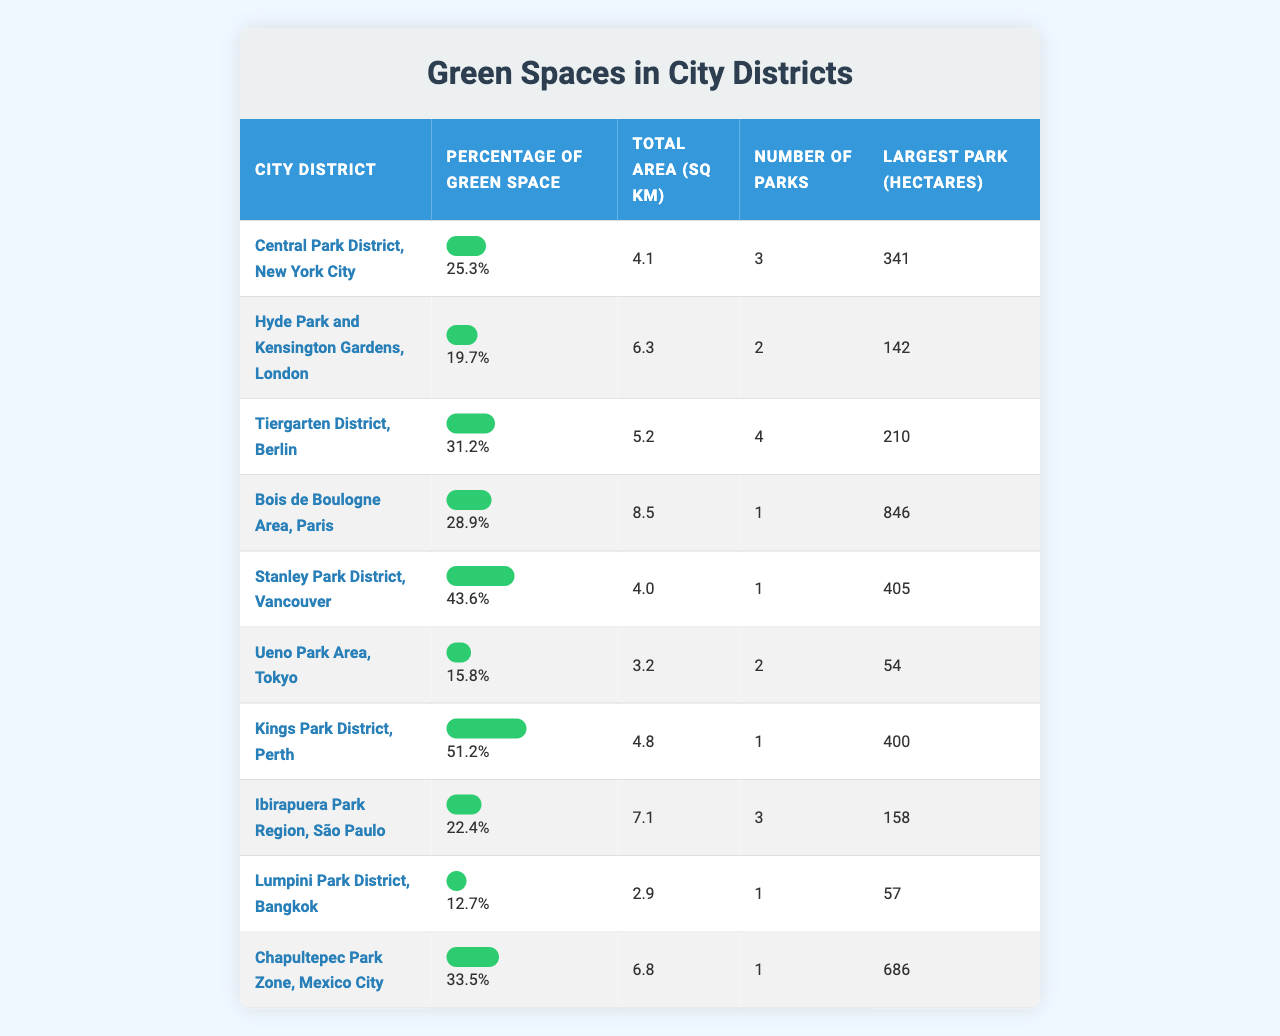What is the percentage of green space in Stanley Park District? From the table, we can see that the entry for Stanley Park District shows a green space percentage of 43.6%.
Answer: 43.6% Which city district has the highest percentage of green space? By reviewing the percentages listed in the table, Kings Park District, with a percentage of 51.2%, has the highest value among all districts.
Answer: Kings Park District How many total hectares does the largest park in Bois de Boulogne Area occupy? The table indicates that Bois de Boulogne Area has its largest park measured at 846 hectares.
Answer: 846 hectares What is the average percentage of green space across the listed city districts? To find the average, we sum the percentages: (25.3 + 19.7 + 31.2 + 28.9 + 43.6 + 15.8 + 51.2 + 22.4 + 12.7 + 33.5) = 389.9. Then, we divide by the number of districts (10), so: 389.9 / 10 = 38.99%.
Answer: 38.99% Is the percentage of green space in Central Park District higher or lower than that in Ueno Park Area? From the table, Central Park District has a green space percentage of 25.3%, while Ueno Park Area has 15.8%. Since 25.3% is greater than 15.8%, the percentage in Central Park District is higher.
Answer: Higher Which city district has the fewest number of parks? From the table, Lumpini Park District is noted to have only 1 park, making it the district with the fewest parks listed.
Answer: Lumpini Park District What is the difference in green space percentage between Tiergarten District and Chapultepec Park Zone? The percentage for Tiergarten District is 31.2% and for Chapultepec Park Zone it is 33.5%. The difference is calculated as 33.5 - 31.2 = 2.3%.
Answer: 2.3% How many total parks are there in all the districts combined? To find the total number of parks, we add the number of parks in each district: (3 + 2 + 4 + 1 + 1 + 2 + 1 + 3 + 1 + 1) = 19.
Answer: 19 parks Which district has a larger total area: Bois de Boulogne Area or Ibirapuera Park Region? The table shows Bois de Boulogne Area has a total area of 8.5 sq km, while Ibirapuera Park Region has 7.1 sq km. Since 8.5 exceeds 7.1, Bois de Boulogne Area has a larger total area.
Answer: Bois de Boulogne Area Is it true that Ueno Park Area has a greater percentage of green space compared to Hyde Park and Kensington Gardens? Comparing the two, Ueno Park Area has 15.8%, and Hyde Park and Kensington Gardens has 19.7%. Thus, since 15.8% is less than 19.7%, the statement is false.
Answer: False 